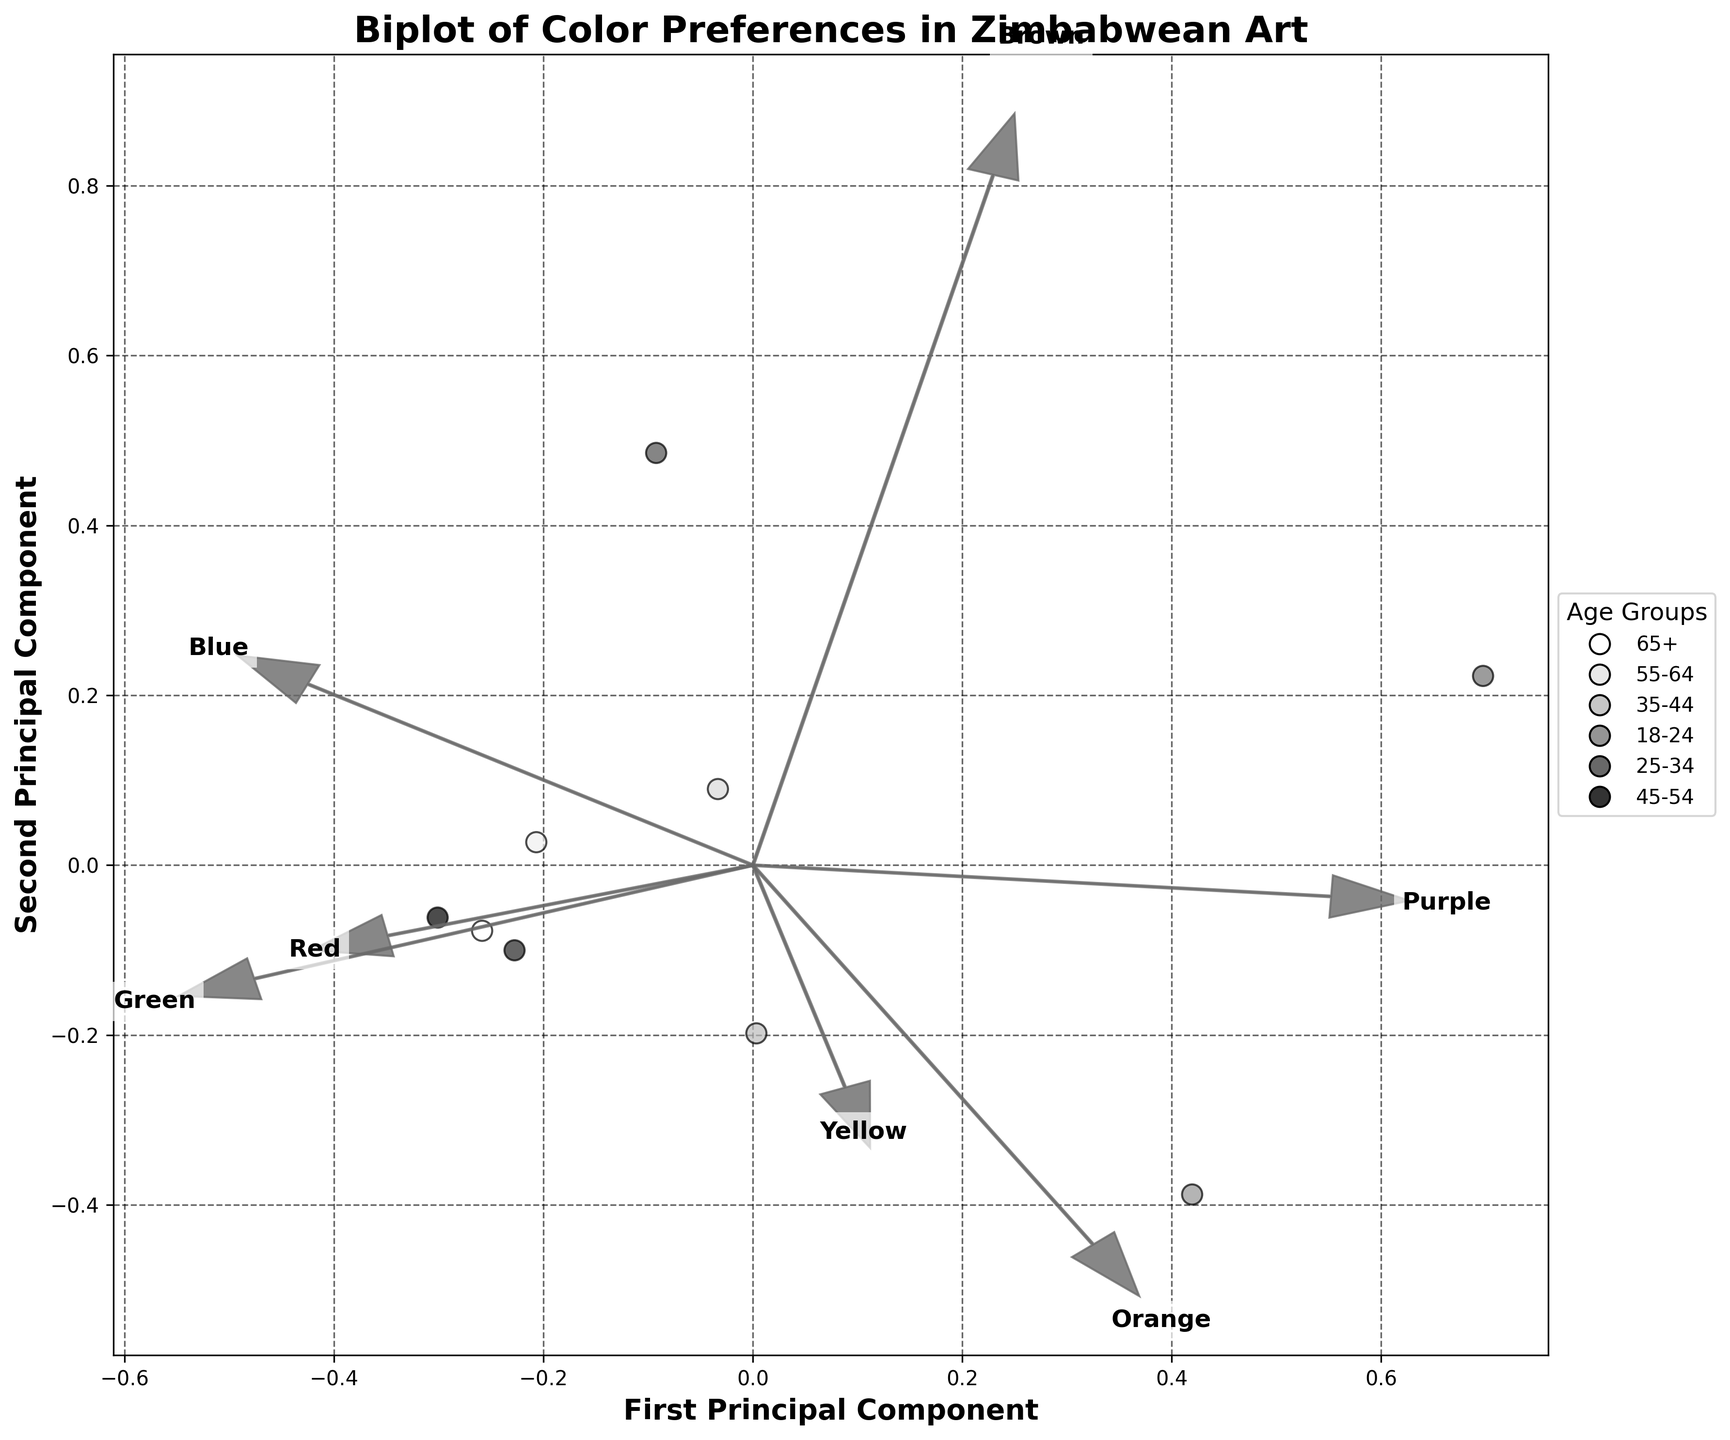What's the title of the figure? The title is displayed at the top of the figure.
Answer: Biplot of Color Preferences in Zimbabwean Art Which age group has the highest preference for red? Look for the point that is farthest along the red vector. Identify the corresponding age group from the legend.
Answer: 45-54 Which color do people in Harare prefer the most, based on the biplot? Locate the point corresponding to Harare and see which color vector it aligns closest to or which vector points towards it the most strongly.
Answer: Blue Is the preference for green higher in the age group 25-34 or in the age group 35-44? Compare the distances along the green vector for the data points representing age groups 25-34 and 35-44.
Answer: 25-34 Which two colors seem to have the most similar preference patterns across age groups and regions? Look at the directions and lengths of the feature vectors; the most similar patterns will have arrows that are close in direction and length.
Answer: Blue and Green Which region shows the least preference for yellow? Find the point that is least aligned with the yellow vector.
Answer: Bulawayo Are there more data points above or below the mean of the first principal component? Count the number of points above and below the average of the First Principal Component axis. The mean is zero by default in PCA.
Answer: Above Is the preference for purple more similar to the preference for orange or yellow across different groups? Compare the feature vectors of purple to orange and yellow; the similar ones will have directions closer to each other.
Answer: Yellow Which colors have vectors pointing in opposite directions, indicating inverse preference patterns? Identify vectors that point in nearly opposite directions on the biplot.
Answer: Red and Green 